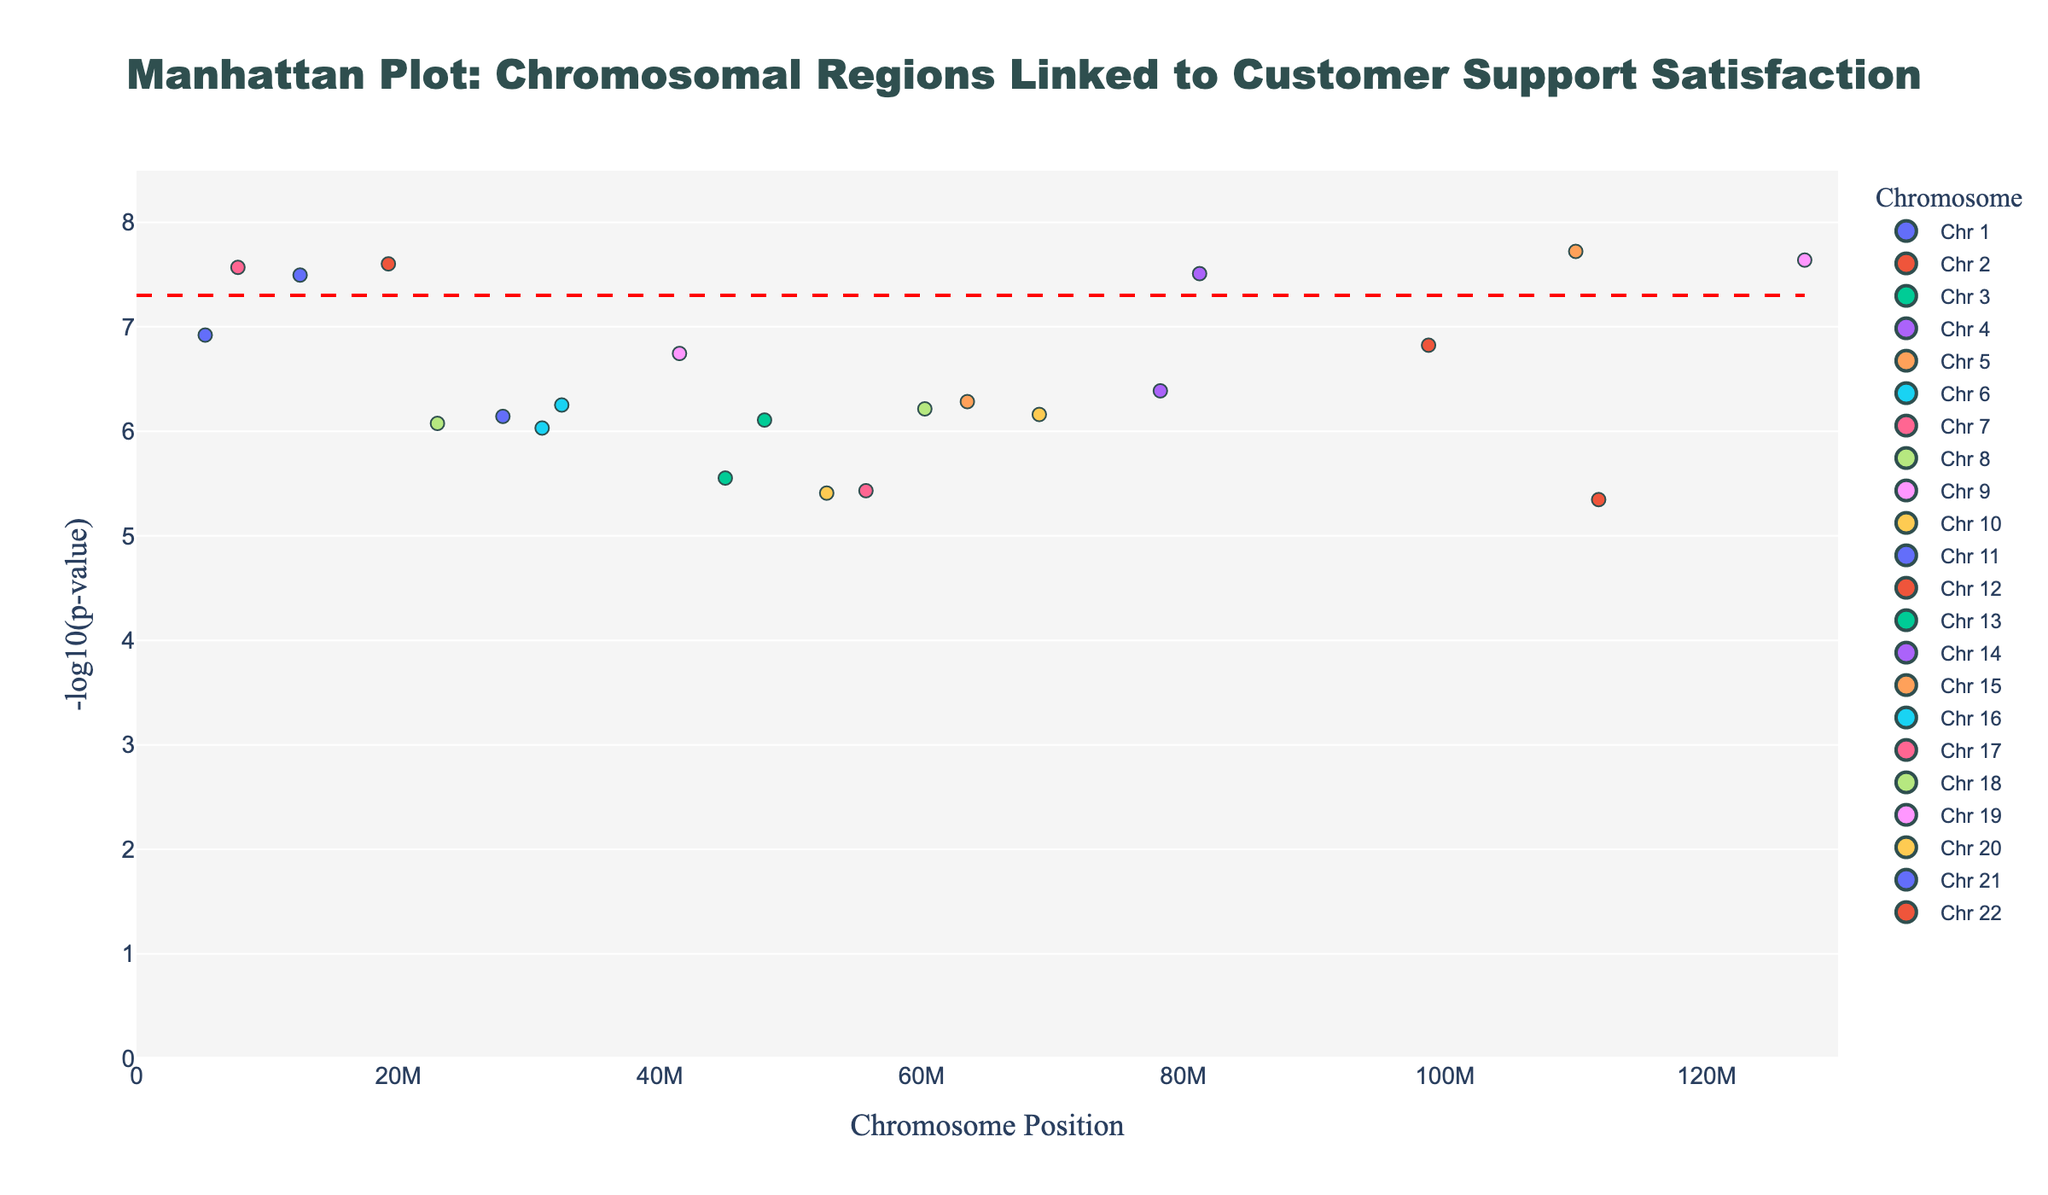What is the title of the figure? The title is usually displayed at the top center of the plot and is typically larger and bolder than other text.
Answer: Manhattan Plot: Chromosomal Regions Linked to Customer Support Satisfaction Which chromosome has the gene with the highest -log10(p-value) and what is the gene? To find this, look for the tallest point on the y-axis and then trace back to the chromosome it belongs to. The hover text feature makes it clear that the gene is TNFRSF1B on chromosome 1.
Answer: Chromosome 1, TNFRSF1B How many points are plotted for chromosome 5? Count the number of markers displayed at different positions along chromosome 5 in the plot.
Answer: 1 What's the range of the -log10(p-value) in the plot? Identify the lowest and highest values on the y-axis that encompasses all the plotted points.
Answer: Approximately 5 to 7.5 What is the significance threshold line and why is it there? The red dashed line, typically located around y = -log10(5e-8), represents the threshold for statistical significance. Any point above this line is considered statistically significant.
Answer: -log10(5e-8), it's there to denote statistical significance Which chromosome has the closest significant genes by position? Compare the scatter points for proximity along the position axis of each chromosome. Chromosome 17 with gene TP53 and Chromosome 18 with gene BCL2 are notably close.
Answer: Chromosome 17 and 18 What is the total number of unique chromosomes presented in the plot? Count the distinct chromosome labels indicated in the legend or by the scatter plots.
Answer: 22 Between TP53 on chromosome 17 and ITGA2 on chromosome 5, which gene has a higher -log10(p-value)? Compare the y-axis values for TP53 and ITGA2. Looking at the heights of their points, TP53 on chromosome 17 is taller.
Answer: TP53 on chromosome 17 What range of positions on chromosome 10 is displayed on the plot and what is the gene identified? Identify the scatter point along chromosome 10 and check the x-axis value. The position for chromosome 10 is around 69000000, and the gene is CTNNA3.
Answer: Around 69000000, CTNNA3 